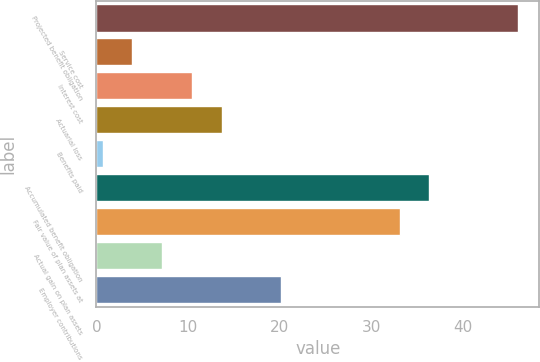Convert chart. <chart><loc_0><loc_0><loc_500><loc_500><bar_chart><fcel>Projected benefit obligation<fcel>Service cost<fcel>Interest cost<fcel>Actuarial loss<fcel>Benefits paid<fcel>Accumulated benefit obligation<fcel>Fair value of plan assets at<fcel>Actual gain on plan assets<fcel>Employer contributions<nl><fcel>46.06<fcel>3.94<fcel>10.42<fcel>13.66<fcel>0.7<fcel>36.34<fcel>33.1<fcel>7.18<fcel>20.14<nl></chart> 